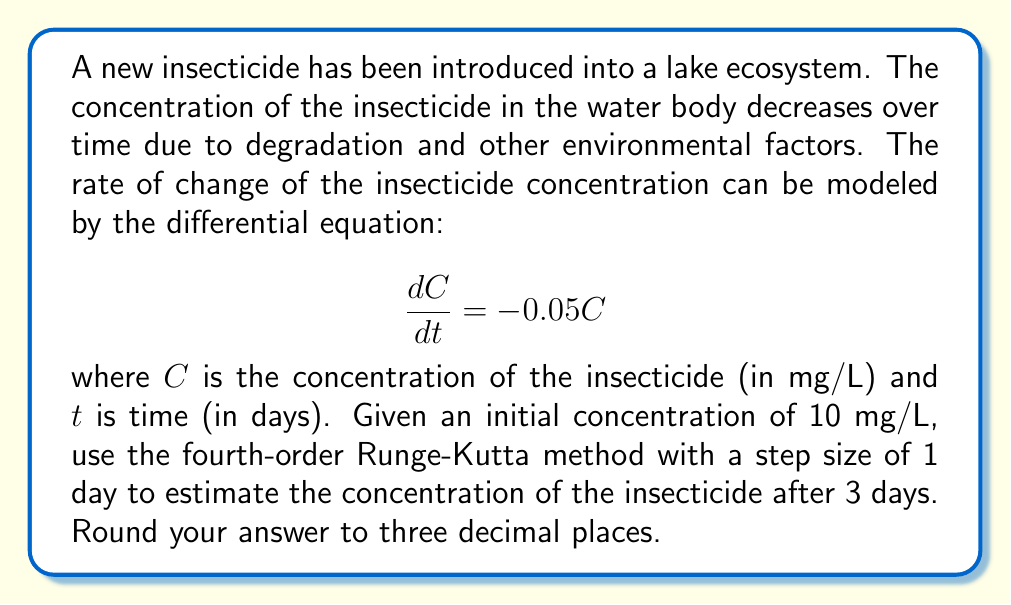What is the answer to this math problem? To solve this problem using the fourth-order Runge-Kutta method, we'll follow these steps:

1) The general form of the fourth-order Runge-Kutta method is:

   $$y_{n+1} = y_n + \frac{1}{6}(k_1 + 2k_2 + 2k_3 + k_4)$$

   where:
   $$k_1 = hf(t_n, y_n)$$
   $$k_2 = hf(t_n + \frac{h}{2}, y_n + \frac{k_1}{2})$$
   $$k_3 = hf(t_n + \frac{h}{2}, y_n + \frac{k_2}{2})$$
   $$k_4 = hf(t_n + h, y_n + k_3)$$

2) In our case, $f(t, C) = -0.05C$, $h = 1$ day, and $C_0 = 10$ mg/L.

3) Let's calculate for each day:

   For day 1:
   $$k_1 = 1 \cdot (-0.05 \cdot 10) = -0.5$$
   $$k_2 = 1 \cdot (-0.05 \cdot (10 - 0.25)) = -0.48750$$
   $$k_3 = 1 \cdot (-0.05 \cdot (10 - 0.24375)) = -0.48781$$
   $$k_4 = 1 \cdot (-0.05 \cdot (10 - 0.48781)) = -0.47561$$

   $$C_1 = 10 + \frac{1}{6}(-0.5 - 2(0.48750) - 2(0.48781) - 0.47561) = 9.50625$$ mg/L

   For day 2:
   $$k_1 = 1 \cdot (-0.05 \cdot 9.50625) = -0.47531$$
   $$k_2 = 1 \cdot (-0.05 \cdot (9.50625 - 0.23766)) = -0.46343$$
   $$k_3 = 1 \cdot (-0.05 \cdot (9.50625 - 0.23172)) = -0.46373$$
   $$k_4 = 1 \cdot (-0.05 \cdot (9.50625 - 0.46373)) = -0.45213$$

   $$C_2 = 9.50625 + \frac{1}{6}(-0.47531 - 2(0.46343) - 2(0.46373) - 0.45213) = 9.03567$$ mg/L

   For day 3:
   $$k_1 = 1 \cdot (-0.05 \cdot 9.03567) = -0.45178$$
   $$k_2 = 1 \cdot (-0.05 \cdot (9.03567 - 0.22589)) = -0.44049$$
   $$k_3 = 1 \cdot (-0.05 \cdot (9.03567 - 0.22025)) = -0.44077$$
   $$k_4 = 1 \cdot (-0.05 \cdot (9.03567 - 0.44077)) = -0.42975$$

   $$C_3 = 9.03567 + \frac{1}{6}(-0.45178 - 2(0.44049) - 2(0.44077) - 0.42975) = 8.58670$$ mg/L

4) Rounding to three decimal places, we get 8.587 mg/L.
Answer: 8.587 mg/L 